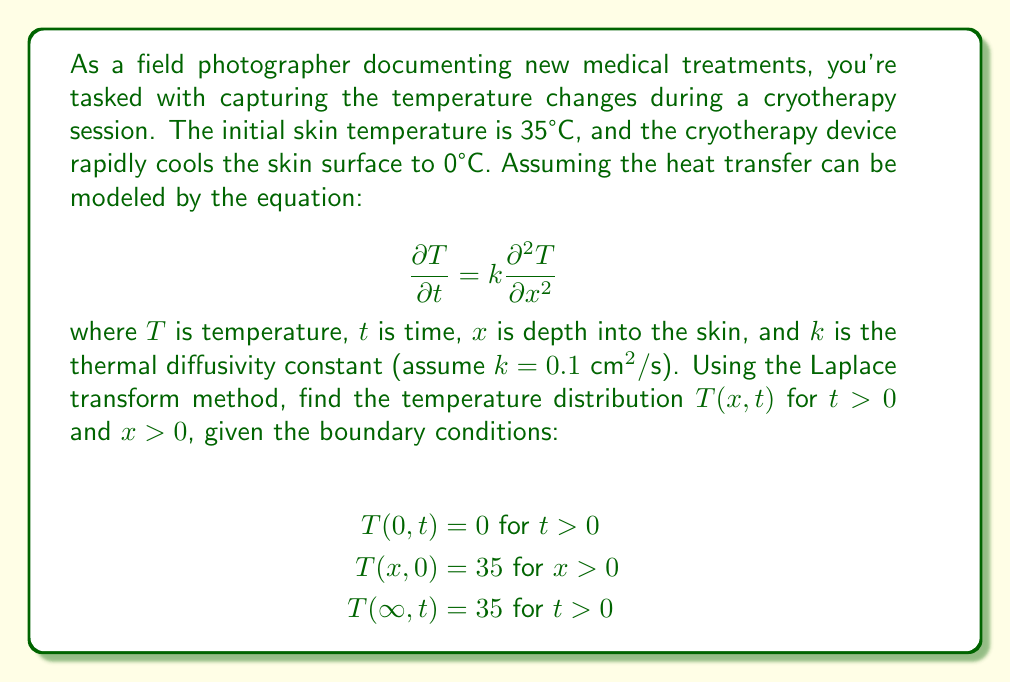Teach me how to tackle this problem. To solve this problem using the Laplace transform method, we'll follow these steps:

1) Take the Laplace transform of the heat equation with respect to $t$:
   $$\mathcal{L}\left\{\frac{\partial T}{\partial t}\right\} = k\mathcal{L}\left\{\frac{\partial^2 T}{\partial x^2}\right\}$$
   $$s\bar{T}(x,s) - T(x,0) = k\frac{d^2\bar{T}(x,s)}{dx^2}$$

2) Substitute the initial condition $T(x,0) = 35$:
   $$s\bar{T}(x,s) - 35 = k\frac{d^2\bar{T}(x,s)}{dx^2}$$

3) Rearrange the equation:
   $$\frac{d^2\bar{T}(x,s)}{dx^2} - \frac{s}{k}\bar{T}(x,s) = -\frac{35}{k}$$

4) The general solution to this ODE is:
   $$\bar{T}(x,s) = A e^{x\sqrt{s/k}} + B e^{-x\sqrt{s/k}} + \frac{35}{s}$$

5) Apply the transformed boundary conditions:
   $\bar{T}(0,s) = 0$ implies $A + B = -\frac{35}{s}$
   $\bar{T}(\infty,s) = \frac{35}{s}$ implies $A = 0$

6) Solve for $B$:
   $$B = -\frac{35}{s}$$

7) Therefore, the transformed solution is:
   $$\bar{T}(x,s) = \frac{35}{s}(1 - e^{-x\sqrt{s/k}})$$

8) Take the inverse Laplace transform:
   $$T(x,t) = 35\left(1 - \text{erf}\left(\frac{x}{2\sqrt{kt}}\right)\right)$$

Where $\text{erf}$ is the error function.
Answer: $T(x,t) = 35\left(1 - \text{erf}\left(\frac{x}{2\sqrt{0.1t}}\right)\right)$ °C 